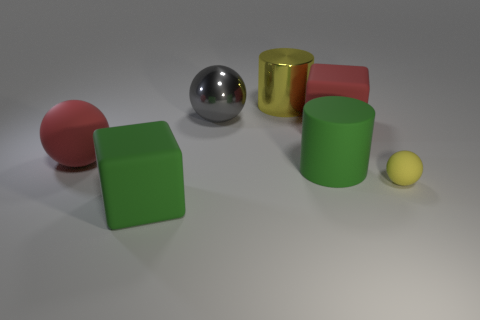Are any tiny yellow metal cylinders visible?
Give a very brief answer. No. There is a rubber block on the left side of the gray metallic object; is it the same size as the large green matte cylinder?
Give a very brief answer. Yes. Are there fewer red rubber things than tiny rubber things?
Provide a short and direct response. No. What shape is the big red matte thing that is left of the big green rubber cube on the left side of the cube right of the rubber cylinder?
Ensure brevity in your answer.  Sphere. Is there a large cylinder made of the same material as the big gray thing?
Your answer should be very brief. Yes. There is a big cylinder that is behind the green rubber cylinder; does it have the same color as the tiny sphere in front of the big yellow object?
Provide a short and direct response. Yes. Is the number of cubes that are to the right of the large yellow object less than the number of big rubber balls?
Keep it short and to the point. No. What number of things are either spheres or large green rubber things to the left of the gray metallic ball?
Your answer should be very brief. 4. The other thing that is the same material as the gray object is what color?
Ensure brevity in your answer.  Yellow. What number of things are either big yellow cylinders or large red matte spheres?
Keep it short and to the point. 2. 